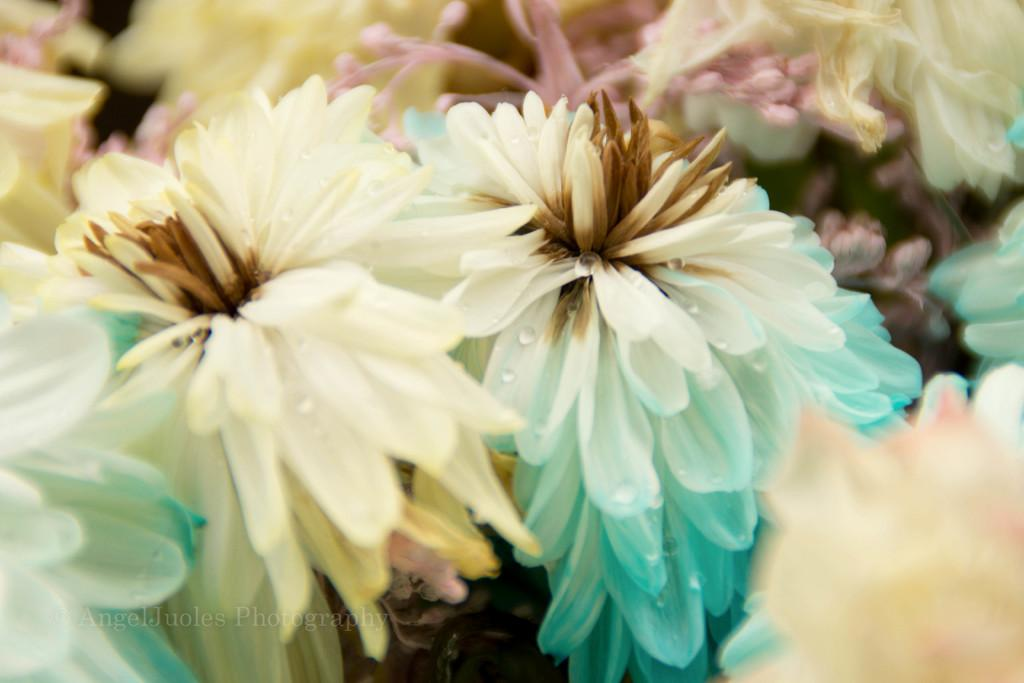What is the main subject in the foreground of the image? There are different types of flowers in the foreground of the image. Can you describe the flowers in more detail? Unfortunately, the facts provided do not give specific details about the flowers. However, we can observe that there are various types of flowers present. What might be the purpose of having flowers in the foreground of the image? The flowers in the foreground could be used to add color, texture, or visual interest to the image. How many chickens are sitting on the flowers in the image? There are no chickens present in the image; it only features different types of flowers in the foreground. 